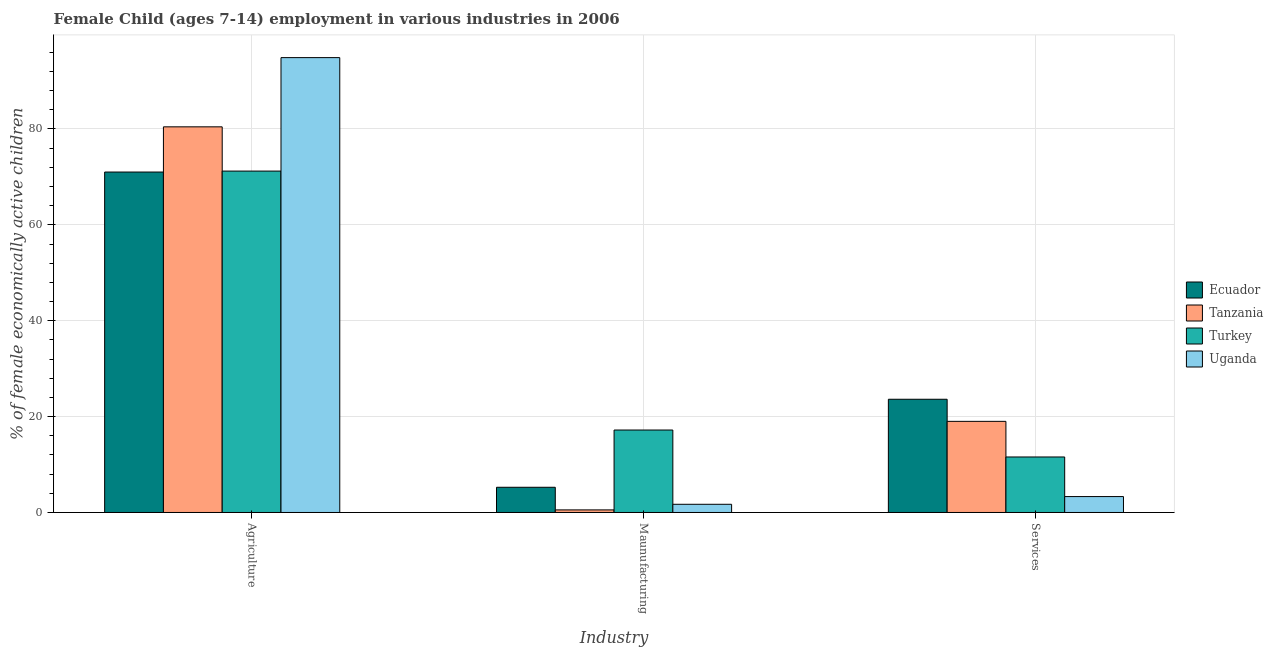How many different coloured bars are there?
Make the answer very short. 4. How many groups of bars are there?
Offer a very short reply. 3. How many bars are there on the 3rd tick from the left?
Give a very brief answer. 4. What is the label of the 1st group of bars from the left?
Your answer should be very brief. Agriculture. What is the percentage of economically active children in services in Uganda?
Your answer should be very brief. 3.32. Across all countries, what is the maximum percentage of economically active children in manufacturing?
Provide a short and direct response. 17.2. Across all countries, what is the minimum percentage of economically active children in agriculture?
Offer a very short reply. 71.02. In which country was the percentage of economically active children in services maximum?
Ensure brevity in your answer.  Ecuador. In which country was the percentage of economically active children in services minimum?
Offer a very short reply. Uganda. What is the total percentage of economically active children in manufacturing in the graph?
Your answer should be very brief. 24.71. What is the difference between the percentage of economically active children in agriculture in Uganda and that in Tanzania?
Ensure brevity in your answer.  14.44. What is the difference between the percentage of economically active children in services in Ecuador and the percentage of economically active children in manufacturing in Uganda?
Your answer should be very brief. 21.91. What is the average percentage of economically active children in services per country?
Provide a short and direct response. 14.38. What is the difference between the percentage of economically active children in services and percentage of economically active children in manufacturing in Tanzania?
Offer a very short reply. 18.47. What is the ratio of the percentage of economically active children in manufacturing in Ecuador to that in Tanzania?
Keep it short and to the point. 9.74. Is the difference between the percentage of economically active children in services in Tanzania and Uganda greater than the difference between the percentage of economically active children in agriculture in Tanzania and Uganda?
Your answer should be very brief. Yes. What is the difference between the highest and the second highest percentage of economically active children in manufacturing?
Offer a terse response. 11.94. What is the difference between the highest and the lowest percentage of economically active children in agriculture?
Keep it short and to the point. 23.87. In how many countries, is the percentage of economically active children in agriculture greater than the average percentage of economically active children in agriculture taken over all countries?
Make the answer very short. 2. What does the 1st bar from the left in Agriculture represents?
Make the answer very short. Ecuador. What does the 1st bar from the right in Services represents?
Offer a very short reply. Uganda. How many bars are there?
Your answer should be very brief. 12. How many countries are there in the graph?
Offer a very short reply. 4. What is the difference between two consecutive major ticks on the Y-axis?
Your response must be concise. 20. Are the values on the major ticks of Y-axis written in scientific E-notation?
Ensure brevity in your answer.  No. Does the graph contain any zero values?
Make the answer very short. No. What is the title of the graph?
Offer a very short reply. Female Child (ages 7-14) employment in various industries in 2006. What is the label or title of the X-axis?
Provide a short and direct response. Industry. What is the label or title of the Y-axis?
Your response must be concise. % of female economically active children. What is the % of female economically active children in Ecuador in Agriculture?
Give a very brief answer. 71.02. What is the % of female economically active children in Tanzania in Agriculture?
Offer a very short reply. 80.45. What is the % of female economically active children in Turkey in Agriculture?
Keep it short and to the point. 71.22. What is the % of female economically active children of Uganda in Agriculture?
Your response must be concise. 94.89. What is the % of female economically active children in Ecuador in Maunufacturing?
Provide a succinct answer. 5.26. What is the % of female economically active children in Tanzania in Maunufacturing?
Make the answer very short. 0.54. What is the % of female economically active children in Uganda in Maunufacturing?
Offer a terse response. 1.71. What is the % of female economically active children in Ecuador in Services?
Your answer should be very brief. 23.62. What is the % of female economically active children in Tanzania in Services?
Ensure brevity in your answer.  19.01. What is the % of female economically active children of Turkey in Services?
Provide a succinct answer. 11.58. What is the % of female economically active children in Uganda in Services?
Your answer should be very brief. 3.32. Across all Industry, what is the maximum % of female economically active children in Ecuador?
Your response must be concise. 71.02. Across all Industry, what is the maximum % of female economically active children of Tanzania?
Your answer should be very brief. 80.45. Across all Industry, what is the maximum % of female economically active children in Turkey?
Your answer should be very brief. 71.22. Across all Industry, what is the maximum % of female economically active children of Uganda?
Keep it short and to the point. 94.89. Across all Industry, what is the minimum % of female economically active children of Ecuador?
Your response must be concise. 5.26. Across all Industry, what is the minimum % of female economically active children in Tanzania?
Offer a terse response. 0.54. Across all Industry, what is the minimum % of female economically active children in Turkey?
Provide a short and direct response. 11.58. Across all Industry, what is the minimum % of female economically active children in Uganda?
Offer a terse response. 1.71. What is the total % of female economically active children in Ecuador in the graph?
Make the answer very short. 99.9. What is the total % of female economically active children in Tanzania in the graph?
Your answer should be very brief. 100. What is the total % of female economically active children in Uganda in the graph?
Give a very brief answer. 99.92. What is the difference between the % of female economically active children in Ecuador in Agriculture and that in Maunufacturing?
Offer a very short reply. 65.76. What is the difference between the % of female economically active children in Tanzania in Agriculture and that in Maunufacturing?
Make the answer very short. 79.91. What is the difference between the % of female economically active children in Turkey in Agriculture and that in Maunufacturing?
Provide a succinct answer. 54.02. What is the difference between the % of female economically active children of Uganda in Agriculture and that in Maunufacturing?
Offer a terse response. 93.18. What is the difference between the % of female economically active children of Ecuador in Agriculture and that in Services?
Your response must be concise. 47.4. What is the difference between the % of female economically active children in Tanzania in Agriculture and that in Services?
Your response must be concise. 61.44. What is the difference between the % of female economically active children of Turkey in Agriculture and that in Services?
Provide a short and direct response. 59.64. What is the difference between the % of female economically active children in Uganda in Agriculture and that in Services?
Provide a succinct answer. 91.57. What is the difference between the % of female economically active children of Ecuador in Maunufacturing and that in Services?
Your response must be concise. -18.36. What is the difference between the % of female economically active children in Tanzania in Maunufacturing and that in Services?
Your answer should be compact. -18.47. What is the difference between the % of female economically active children in Turkey in Maunufacturing and that in Services?
Give a very brief answer. 5.62. What is the difference between the % of female economically active children in Uganda in Maunufacturing and that in Services?
Your answer should be compact. -1.61. What is the difference between the % of female economically active children in Ecuador in Agriculture and the % of female economically active children in Tanzania in Maunufacturing?
Offer a very short reply. 70.48. What is the difference between the % of female economically active children of Ecuador in Agriculture and the % of female economically active children of Turkey in Maunufacturing?
Offer a very short reply. 53.82. What is the difference between the % of female economically active children of Ecuador in Agriculture and the % of female economically active children of Uganda in Maunufacturing?
Give a very brief answer. 69.31. What is the difference between the % of female economically active children of Tanzania in Agriculture and the % of female economically active children of Turkey in Maunufacturing?
Keep it short and to the point. 63.25. What is the difference between the % of female economically active children in Tanzania in Agriculture and the % of female economically active children in Uganda in Maunufacturing?
Offer a terse response. 78.74. What is the difference between the % of female economically active children in Turkey in Agriculture and the % of female economically active children in Uganda in Maunufacturing?
Ensure brevity in your answer.  69.51. What is the difference between the % of female economically active children in Ecuador in Agriculture and the % of female economically active children in Tanzania in Services?
Your answer should be compact. 52.01. What is the difference between the % of female economically active children in Ecuador in Agriculture and the % of female economically active children in Turkey in Services?
Offer a very short reply. 59.44. What is the difference between the % of female economically active children in Ecuador in Agriculture and the % of female economically active children in Uganda in Services?
Offer a terse response. 67.7. What is the difference between the % of female economically active children in Tanzania in Agriculture and the % of female economically active children in Turkey in Services?
Your answer should be very brief. 68.87. What is the difference between the % of female economically active children of Tanzania in Agriculture and the % of female economically active children of Uganda in Services?
Give a very brief answer. 77.13. What is the difference between the % of female economically active children in Turkey in Agriculture and the % of female economically active children in Uganda in Services?
Your answer should be compact. 67.9. What is the difference between the % of female economically active children in Ecuador in Maunufacturing and the % of female economically active children in Tanzania in Services?
Offer a terse response. -13.75. What is the difference between the % of female economically active children of Ecuador in Maunufacturing and the % of female economically active children of Turkey in Services?
Provide a succinct answer. -6.32. What is the difference between the % of female economically active children in Ecuador in Maunufacturing and the % of female economically active children in Uganda in Services?
Provide a succinct answer. 1.94. What is the difference between the % of female economically active children of Tanzania in Maunufacturing and the % of female economically active children of Turkey in Services?
Provide a short and direct response. -11.04. What is the difference between the % of female economically active children in Tanzania in Maunufacturing and the % of female economically active children in Uganda in Services?
Give a very brief answer. -2.78. What is the difference between the % of female economically active children in Turkey in Maunufacturing and the % of female economically active children in Uganda in Services?
Your answer should be very brief. 13.88. What is the average % of female economically active children of Ecuador per Industry?
Offer a terse response. 33.3. What is the average % of female economically active children in Tanzania per Industry?
Your answer should be compact. 33.33. What is the average % of female economically active children of Turkey per Industry?
Give a very brief answer. 33.33. What is the average % of female economically active children of Uganda per Industry?
Your answer should be compact. 33.31. What is the difference between the % of female economically active children in Ecuador and % of female economically active children in Tanzania in Agriculture?
Make the answer very short. -9.43. What is the difference between the % of female economically active children in Ecuador and % of female economically active children in Turkey in Agriculture?
Your answer should be compact. -0.2. What is the difference between the % of female economically active children in Ecuador and % of female economically active children in Uganda in Agriculture?
Provide a succinct answer. -23.87. What is the difference between the % of female economically active children in Tanzania and % of female economically active children in Turkey in Agriculture?
Provide a succinct answer. 9.23. What is the difference between the % of female economically active children in Tanzania and % of female economically active children in Uganda in Agriculture?
Offer a terse response. -14.44. What is the difference between the % of female economically active children in Turkey and % of female economically active children in Uganda in Agriculture?
Keep it short and to the point. -23.67. What is the difference between the % of female economically active children in Ecuador and % of female economically active children in Tanzania in Maunufacturing?
Make the answer very short. 4.72. What is the difference between the % of female economically active children in Ecuador and % of female economically active children in Turkey in Maunufacturing?
Make the answer very short. -11.94. What is the difference between the % of female economically active children of Ecuador and % of female economically active children of Uganda in Maunufacturing?
Your answer should be very brief. 3.55. What is the difference between the % of female economically active children of Tanzania and % of female economically active children of Turkey in Maunufacturing?
Make the answer very short. -16.66. What is the difference between the % of female economically active children of Tanzania and % of female economically active children of Uganda in Maunufacturing?
Provide a short and direct response. -1.17. What is the difference between the % of female economically active children of Turkey and % of female economically active children of Uganda in Maunufacturing?
Make the answer very short. 15.49. What is the difference between the % of female economically active children in Ecuador and % of female economically active children in Tanzania in Services?
Provide a short and direct response. 4.61. What is the difference between the % of female economically active children of Ecuador and % of female economically active children of Turkey in Services?
Your response must be concise. 12.04. What is the difference between the % of female economically active children in Ecuador and % of female economically active children in Uganda in Services?
Offer a terse response. 20.3. What is the difference between the % of female economically active children in Tanzania and % of female economically active children in Turkey in Services?
Offer a terse response. 7.43. What is the difference between the % of female economically active children in Tanzania and % of female economically active children in Uganda in Services?
Offer a very short reply. 15.69. What is the difference between the % of female economically active children of Turkey and % of female economically active children of Uganda in Services?
Your response must be concise. 8.26. What is the ratio of the % of female economically active children of Ecuador in Agriculture to that in Maunufacturing?
Provide a succinct answer. 13.5. What is the ratio of the % of female economically active children in Tanzania in Agriculture to that in Maunufacturing?
Offer a terse response. 148.98. What is the ratio of the % of female economically active children of Turkey in Agriculture to that in Maunufacturing?
Make the answer very short. 4.14. What is the ratio of the % of female economically active children in Uganda in Agriculture to that in Maunufacturing?
Provide a succinct answer. 55.49. What is the ratio of the % of female economically active children in Ecuador in Agriculture to that in Services?
Make the answer very short. 3.01. What is the ratio of the % of female economically active children of Tanzania in Agriculture to that in Services?
Offer a very short reply. 4.23. What is the ratio of the % of female economically active children of Turkey in Agriculture to that in Services?
Keep it short and to the point. 6.15. What is the ratio of the % of female economically active children in Uganda in Agriculture to that in Services?
Give a very brief answer. 28.58. What is the ratio of the % of female economically active children of Ecuador in Maunufacturing to that in Services?
Offer a terse response. 0.22. What is the ratio of the % of female economically active children of Tanzania in Maunufacturing to that in Services?
Make the answer very short. 0.03. What is the ratio of the % of female economically active children of Turkey in Maunufacturing to that in Services?
Provide a succinct answer. 1.49. What is the ratio of the % of female economically active children in Uganda in Maunufacturing to that in Services?
Your response must be concise. 0.52. What is the difference between the highest and the second highest % of female economically active children of Ecuador?
Your response must be concise. 47.4. What is the difference between the highest and the second highest % of female economically active children in Tanzania?
Your answer should be very brief. 61.44. What is the difference between the highest and the second highest % of female economically active children in Turkey?
Your response must be concise. 54.02. What is the difference between the highest and the second highest % of female economically active children of Uganda?
Make the answer very short. 91.57. What is the difference between the highest and the lowest % of female economically active children of Ecuador?
Offer a terse response. 65.76. What is the difference between the highest and the lowest % of female economically active children of Tanzania?
Provide a succinct answer. 79.91. What is the difference between the highest and the lowest % of female economically active children of Turkey?
Ensure brevity in your answer.  59.64. What is the difference between the highest and the lowest % of female economically active children in Uganda?
Provide a succinct answer. 93.18. 